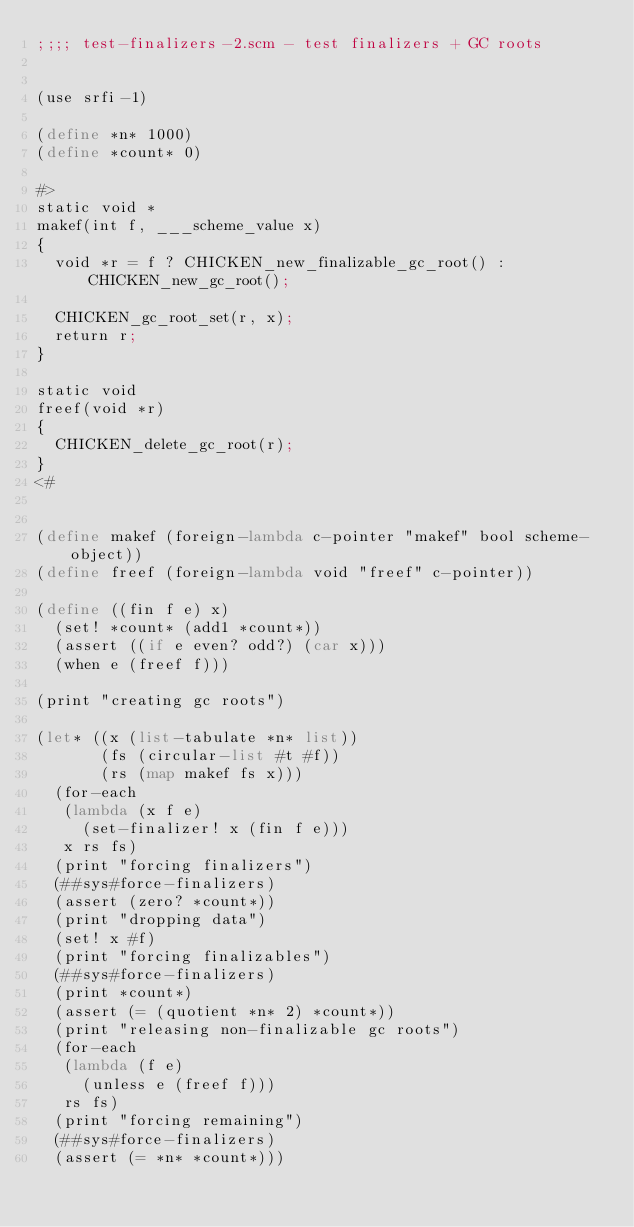<code> <loc_0><loc_0><loc_500><loc_500><_Scheme_>;;;; test-finalizers-2.scm - test finalizers + GC roots


(use srfi-1)

(define *n* 1000)
(define *count* 0)

#>
static void *
makef(int f, ___scheme_value x)
{
  void *r = f ? CHICKEN_new_finalizable_gc_root() : CHICKEN_new_gc_root();

  CHICKEN_gc_root_set(r, x);
  return r;
}

static void
freef(void *r)
{
  CHICKEN_delete_gc_root(r);
}
<#


(define makef (foreign-lambda c-pointer "makef" bool scheme-object))
(define freef (foreign-lambda void "freef" c-pointer))

(define ((fin f e) x)
  (set! *count* (add1 *count*))
  (assert ((if e even? odd?) (car x)))
  (when e (freef f)))

(print "creating gc roots")

(let* ((x (list-tabulate *n* list))
       (fs (circular-list #t #f))
       (rs (map makef fs x)))
  (for-each 
   (lambda (x f e)
     (set-finalizer! x (fin f e)))
   x rs fs)
  (print "forcing finalizers")
  (##sys#force-finalizers)
  (assert (zero? *count*))
  (print "dropping data")
  (set! x #f)
  (print "forcing finalizables")
  (##sys#force-finalizers)
  (print *count*)
  (assert (= (quotient *n* 2) *count*))
  (print "releasing non-finalizable gc roots")
  (for-each 
   (lambda (f e)
     (unless e (freef f)))
   rs fs)
  (print "forcing remaining")
  (##sys#force-finalizers)
  (assert (= *n* *count*)))
</code> 